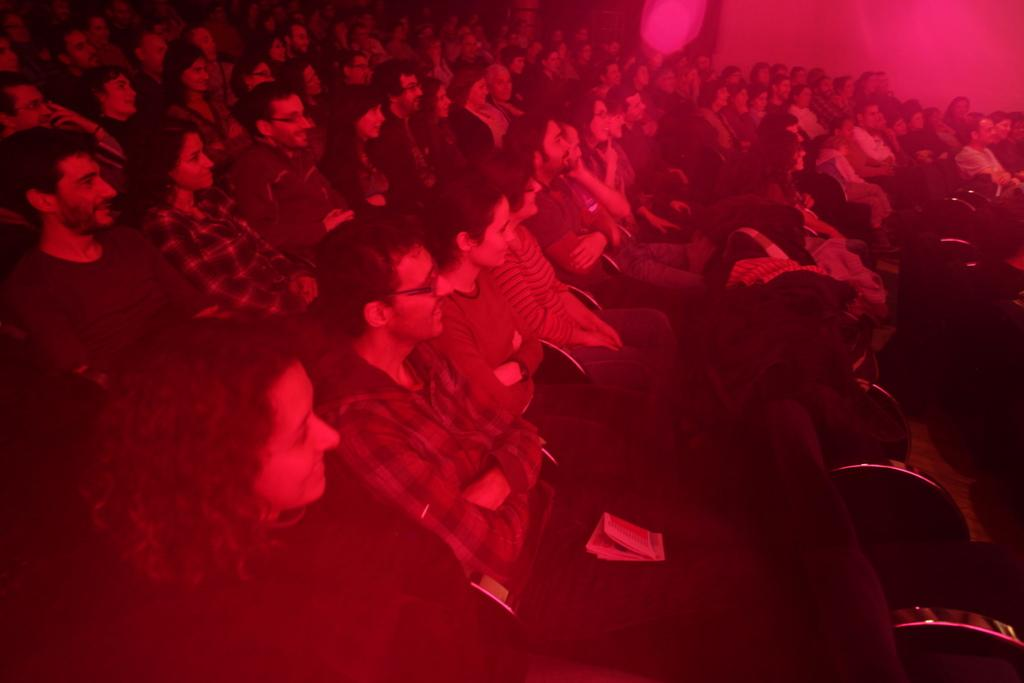How many people are in the image? There are a few people in the image. What are the people doing in the image? The people are sitting on chairs. What type of pencil is being used by the people in the image? There is no pencil present in the image; the people are sitting on chairs. What musical instrument is being played by the people in the image? There is no musical instrument present in the image; the people are sitting on chairs. 